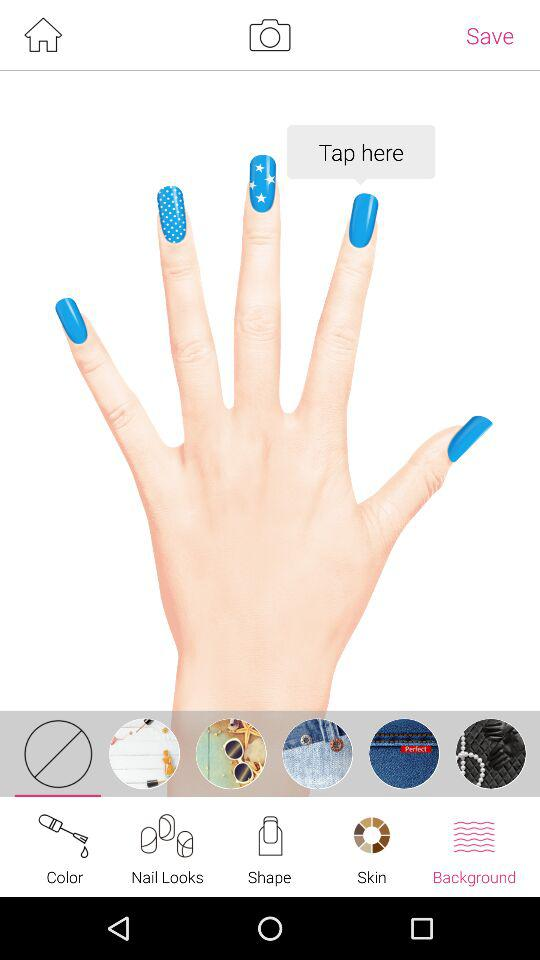Which tab am I on? You are on the "Background" tab. 